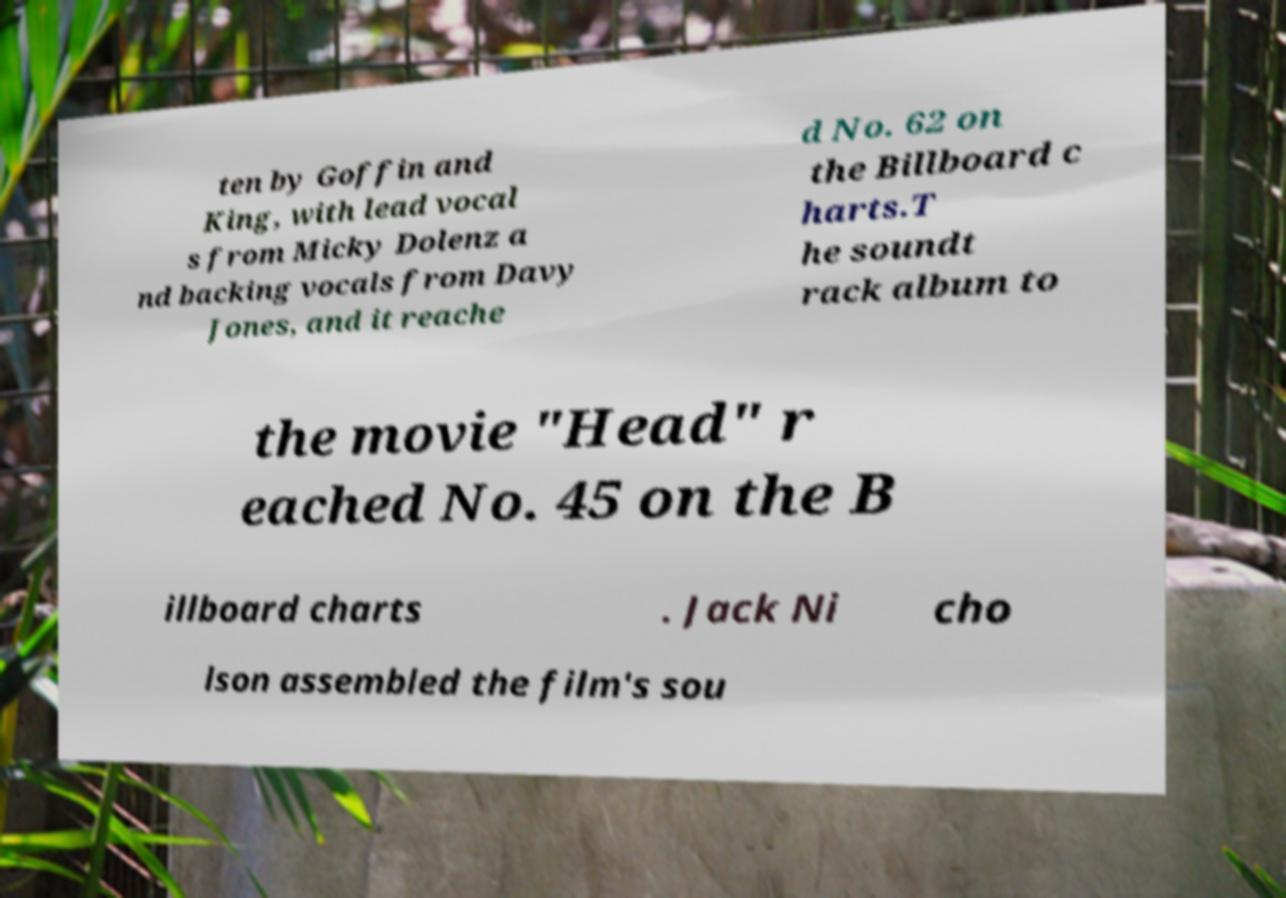Please identify and transcribe the text found in this image. ten by Goffin and King, with lead vocal s from Micky Dolenz a nd backing vocals from Davy Jones, and it reache d No. 62 on the Billboard c harts.T he soundt rack album to the movie "Head" r eached No. 45 on the B illboard charts . Jack Ni cho lson assembled the film's sou 